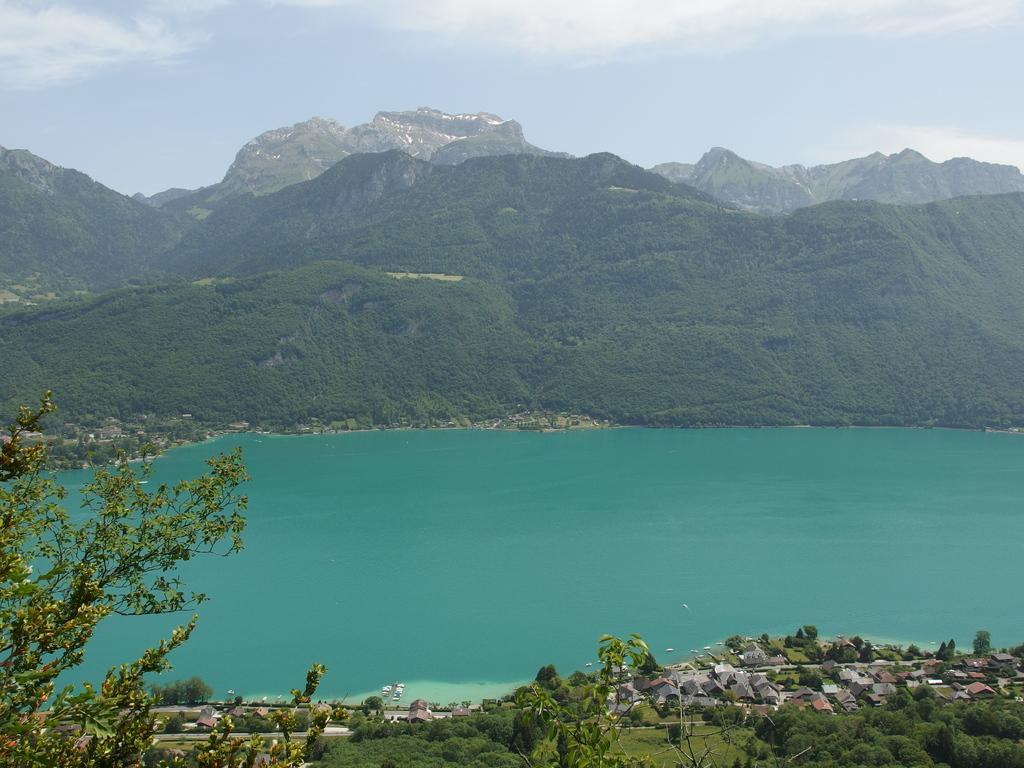Can you describe this image briefly? In this picture we can see houses, trees, and water. In the background we can see mountains and sky. 